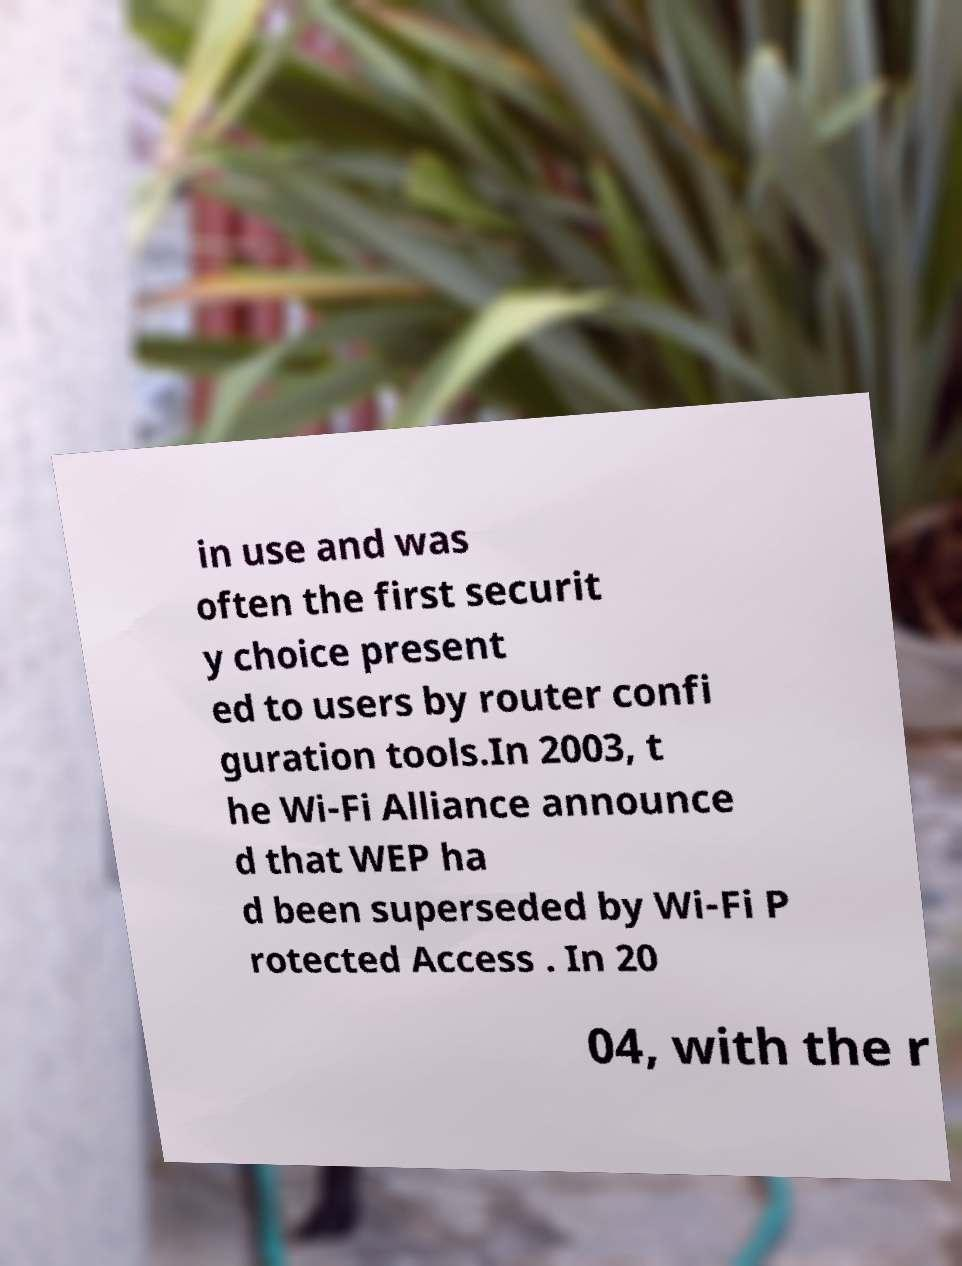Please read and relay the text visible in this image. What does it say? in use and was often the first securit y choice present ed to users by router confi guration tools.In 2003, t he Wi-Fi Alliance announce d that WEP ha d been superseded by Wi-Fi P rotected Access . In 20 04, with the r 